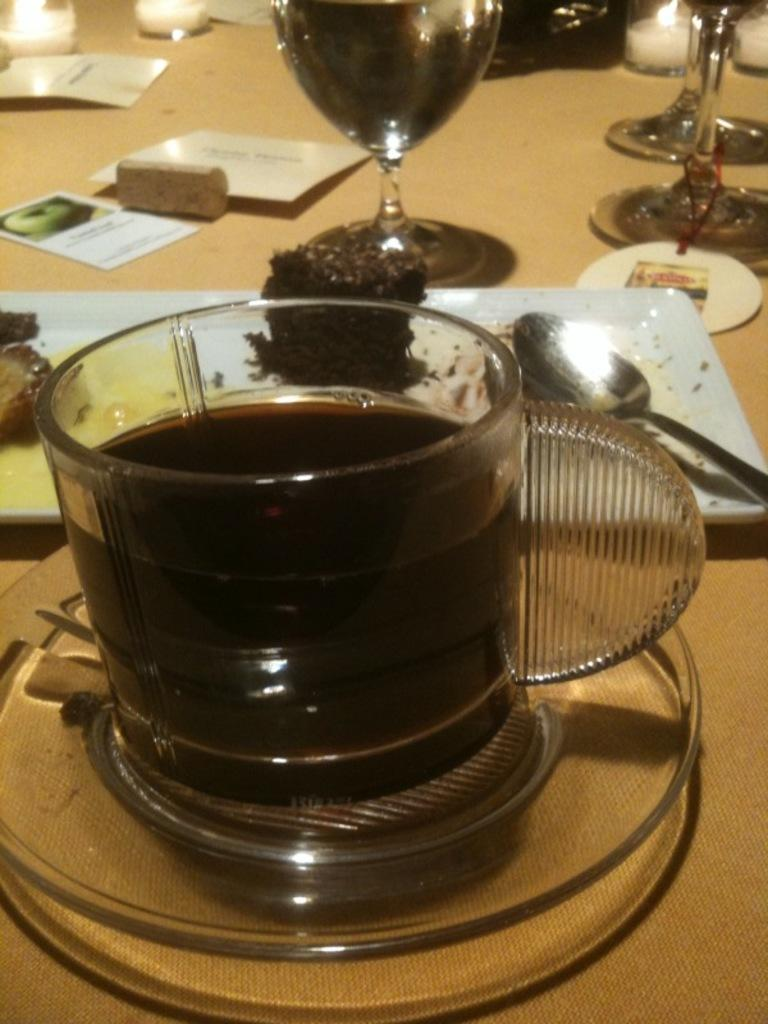What piece of furniture is present in the image? There is a table in the image. What is placed on the table? There is a cup, a saucer, tea, a plate, a spoon, a brownie, a glass, wine, and a candle on the table. What type of drink is in the glass? There is wine in the glass. What type of food is on the table? There is a brownie on the table, which is a type of food. How many trips does the brownie take to reach the glass? The brownie does not take any trips in the image; it is stationary on the table. What is the fifth item on the table? There is no specific mention of a fifth item on the table, as the list of items is not numbered. 